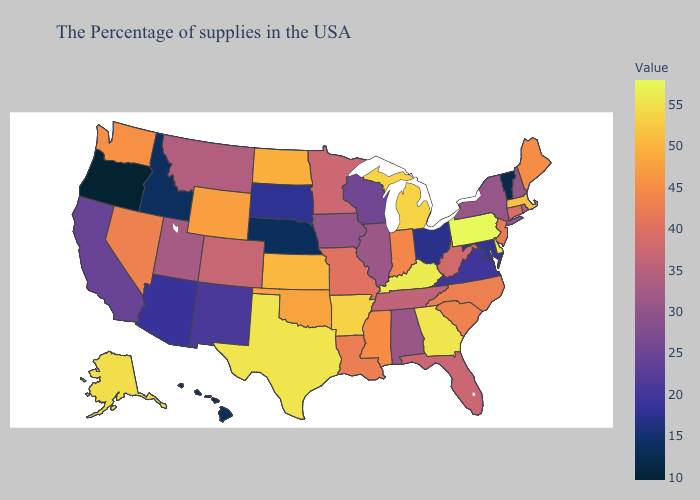Does Nevada have a lower value than Massachusetts?
Keep it brief. Yes. Does New York have the lowest value in the Northeast?
Give a very brief answer. No. Among the states that border Wisconsin , does Iowa have the highest value?
Short answer required. No. Which states have the lowest value in the USA?
Short answer required. Oregon. Which states have the lowest value in the South?
Be succinct. Maryland. 